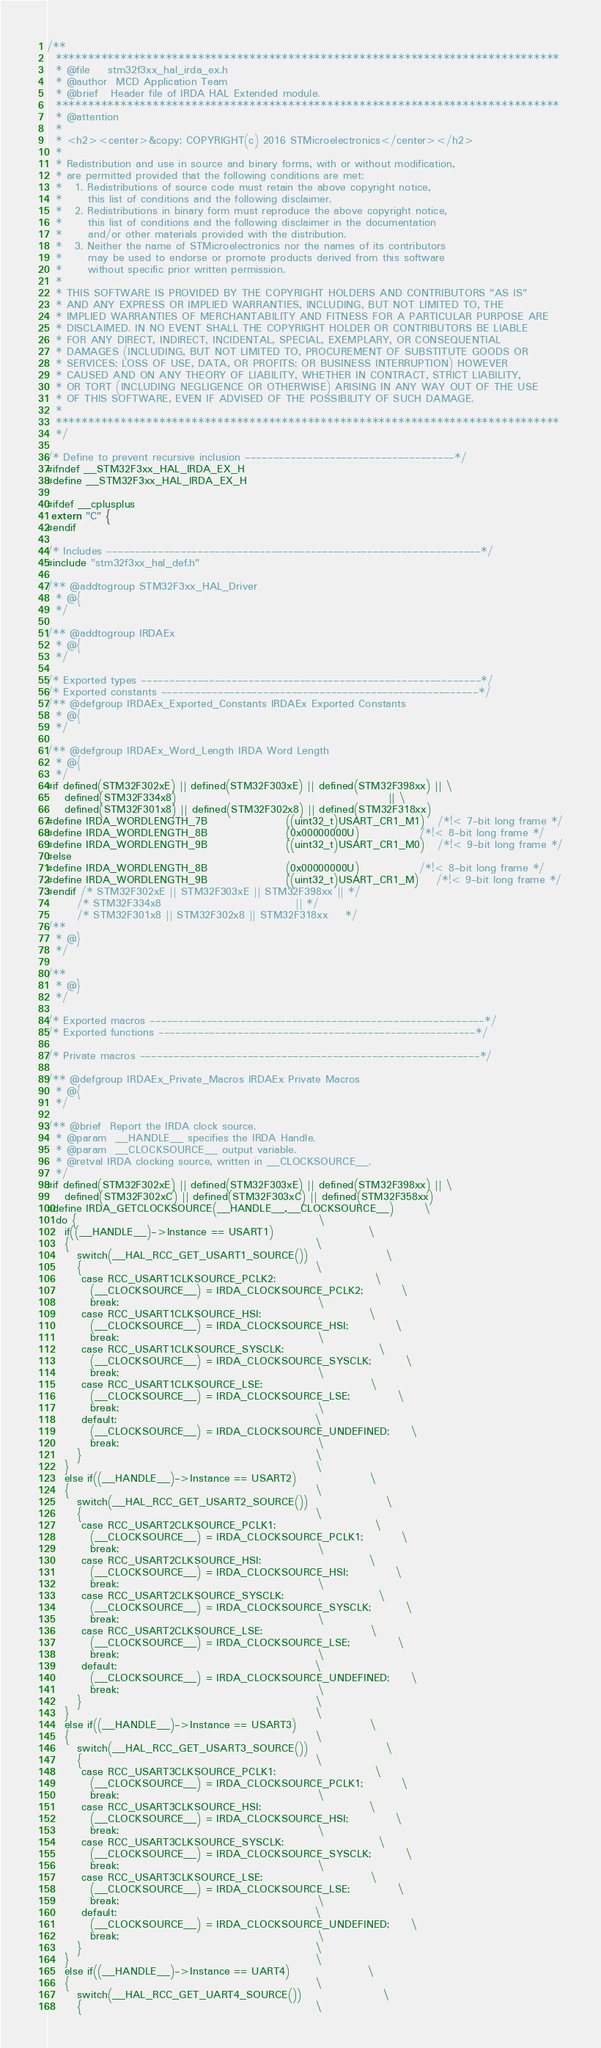Convert code to text. <code><loc_0><loc_0><loc_500><loc_500><_C_>/**
  ******************************************************************************
  * @file    stm32f3xx_hal_irda_ex.h
  * @author  MCD Application Team
  * @brief   Header file of IRDA HAL Extended module.
  ******************************************************************************
  * @attention
  *
  * <h2><center>&copy; COPYRIGHT(c) 2016 STMicroelectronics</center></h2>
  *
  * Redistribution and use in source and binary forms, with or without modification,
  * are permitted provided that the following conditions are met:
  *   1. Redistributions of source code must retain the above copyright notice,
  *      this list of conditions and the following disclaimer.
  *   2. Redistributions in binary form must reproduce the above copyright notice,
  *      this list of conditions and the following disclaimer in the documentation
  *      and/or other materials provided with the distribution.
  *   3. Neither the name of STMicroelectronics nor the names of its contributors
  *      may be used to endorse or promote products derived from this software
  *      without specific prior written permission.
  *
  * THIS SOFTWARE IS PROVIDED BY THE COPYRIGHT HOLDERS AND CONTRIBUTORS "AS IS"
  * AND ANY EXPRESS OR IMPLIED WARRANTIES, INCLUDING, BUT NOT LIMITED TO, THE
  * IMPLIED WARRANTIES OF MERCHANTABILITY AND FITNESS FOR A PARTICULAR PURPOSE ARE
  * DISCLAIMED. IN NO EVENT SHALL THE COPYRIGHT HOLDER OR CONTRIBUTORS BE LIABLE
  * FOR ANY DIRECT, INDIRECT, INCIDENTAL, SPECIAL, EXEMPLARY, OR CONSEQUENTIAL
  * DAMAGES (INCLUDING, BUT NOT LIMITED TO, PROCUREMENT OF SUBSTITUTE GOODS OR
  * SERVICES; LOSS OF USE, DATA, OR PROFITS; OR BUSINESS INTERRUPTION) HOWEVER
  * CAUSED AND ON ANY THEORY OF LIABILITY, WHETHER IN CONTRACT, STRICT LIABILITY,
  * OR TORT (INCLUDING NEGLIGENCE OR OTHERWISE) ARISING IN ANY WAY OUT OF THE USE
  * OF THIS SOFTWARE, EVEN IF ADVISED OF THE POSSIBILITY OF SUCH DAMAGE.
  *
  ******************************************************************************
  */

/* Define to prevent recursive inclusion -------------------------------------*/
#ifndef __STM32F3xx_HAL_IRDA_EX_H
#define __STM32F3xx_HAL_IRDA_EX_H

#ifdef __cplusplus
 extern "C" {
#endif

/* Includes ------------------------------------------------------------------*/
#include "stm32f3xx_hal_def.h"

/** @addtogroup STM32F3xx_HAL_Driver
  * @{
  */

/** @addtogroup IRDAEx
  * @{
  */

/* Exported types ------------------------------------------------------------*/
/* Exported constants --------------------------------------------------------*/
/** @defgroup IRDAEx_Exported_Constants IRDAEx Exported Constants
  * @{
  */

/** @defgroup IRDAEx_Word_Length IRDA Word Length
  * @{
  */
#if defined(STM32F302xE) || defined(STM32F303xE) || defined(STM32F398xx) || \
    defined(STM32F334x8)                                                 || \
    defined(STM32F301x8) || defined(STM32F302x8) || defined(STM32F318xx)
#define IRDA_WORDLENGTH_7B                  ((uint32_t)USART_CR1_M1)   /*!< 7-bit long frame */
#define IRDA_WORDLENGTH_8B                  (0x00000000U)              /*!< 8-bit long frame */
#define IRDA_WORDLENGTH_9B                  ((uint32_t)USART_CR1_M0)   /*!< 9-bit long frame */
#else
#define IRDA_WORDLENGTH_8B                  (0x00000000U)              /*!< 8-bit long frame */
#define IRDA_WORDLENGTH_9B                  ((uint32_t)USART_CR1_M)    /*!< 9-bit long frame */
#endif /* STM32F302xE || STM32F303xE || STM32F398xx || */
       /* STM32F334x8                               || */
       /* STM32F301x8 || STM32F302x8 || STM32F318xx    */
/**
  * @}
  */
    
/**
  * @}
  */  

/* Exported macros -----------------------------------------------------------*/
/* Exported functions --------------------------------------------------------*/

/* Private macros ------------------------------------------------------------*/

/** @defgroup IRDAEx_Private_Macros IRDAEx Private Macros
  * @{
  */

/** @brief  Report the IRDA clock source.
  * @param  __HANDLE__ specifies the IRDA Handle.
  * @param  __CLOCKSOURCE__ output variable.
  * @retval IRDA clocking source, written in __CLOCKSOURCE__.
  */
#if defined(STM32F302xE) || defined(STM32F303xE) || defined(STM32F398xx) || \
    defined(STM32F302xC) || defined(STM32F303xC) || defined(STM32F358xx)
#define IRDA_GETCLOCKSOURCE(__HANDLE__,__CLOCKSOURCE__)       \
  do {                                                        \
    if((__HANDLE__)->Instance == USART1)                      \
    {                                                         \
       switch(__HAL_RCC_GET_USART1_SOURCE())                  \
       {                                                      \
        case RCC_USART1CLKSOURCE_PCLK2:                       \
          (__CLOCKSOURCE__) = IRDA_CLOCKSOURCE_PCLK2;         \
          break;                                              \
        case RCC_USART1CLKSOURCE_HSI:                         \
          (__CLOCKSOURCE__) = IRDA_CLOCKSOURCE_HSI;           \
          break;                                              \
        case RCC_USART1CLKSOURCE_SYSCLK:                      \
          (__CLOCKSOURCE__) = IRDA_CLOCKSOURCE_SYSCLK;        \
          break;                                              \
        case RCC_USART1CLKSOURCE_LSE:                         \
          (__CLOCKSOURCE__) = IRDA_CLOCKSOURCE_LSE;           \
          break;                                              \
        default:                                              \
          (__CLOCKSOURCE__) = IRDA_CLOCKSOURCE_UNDEFINED;     \
          break;                                              \
       }                                                      \
    }                                                         \
    else if((__HANDLE__)->Instance == USART2)                 \
    {                                                         \
       switch(__HAL_RCC_GET_USART2_SOURCE())                  \
       {                                                      \
        case RCC_USART2CLKSOURCE_PCLK1:                       \
          (__CLOCKSOURCE__) = IRDA_CLOCKSOURCE_PCLK1;         \
          break;                                              \
        case RCC_USART2CLKSOURCE_HSI:                         \
          (__CLOCKSOURCE__) = IRDA_CLOCKSOURCE_HSI;           \
          break;                                              \
        case RCC_USART2CLKSOURCE_SYSCLK:                      \
          (__CLOCKSOURCE__) = IRDA_CLOCKSOURCE_SYSCLK;        \
          break;                                              \
        case RCC_USART2CLKSOURCE_LSE:                         \
          (__CLOCKSOURCE__) = IRDA_CLOCKSOURCE_LSE;           \
          break;                                              \
        default:                                              \
          (__CLOCKSOURCE__) = IRDA_CLOCKSOURCE_UNDEFINED;     \
          break;                                              \
       }                                                      \
    }                                                         \
    else if((__HANDLE__)->Instance == USART3)                 \
    {                                                         \
       switch(__HAL_RCC_GET_USART3_SOURCE())                  \
       {                                                      \
        case RCC_USART3CLKSOURCE_PCLK1:                       \
          (__CLOCKSOURCE__) = IRDA_CLOCKSOURCE_PCLK1;         \
          break;                                              \
        case RCC_USART3CLKSOURCE_HSI:                         \
          (__CLOCKSOURCE__) = IRDA_CLOCKSOURCE_HSI;           \
          break;                                              \
        case RCC_USART3CLKSOURCE_SYSCLK:                      \
          (__CLOCKSOURCE__) = IRDA_CLOCKSOURCE_SYSCLK;        \
          break;                                              \
        case RCC_USART3CLKSOURCE_LSE:                         \
          (__CLOCKSOURCE__) = IRDA_CLOCKSOURCE_LSE;           \
          break;                                              \
        default:                                              \
          (__CLOCKSOURCE__) = IRDA_CLOCKSOURCE_UNDEFINED;     \
          break;                                              \
       }                                                      \
    }                                                         \
    else if((__HANDLE__)->Instance == UART4)                  \
    {                                                         \
       switch(__HAL_RCC_GET_UART4_SOURCE())                   \
       {                                                      \</code> 